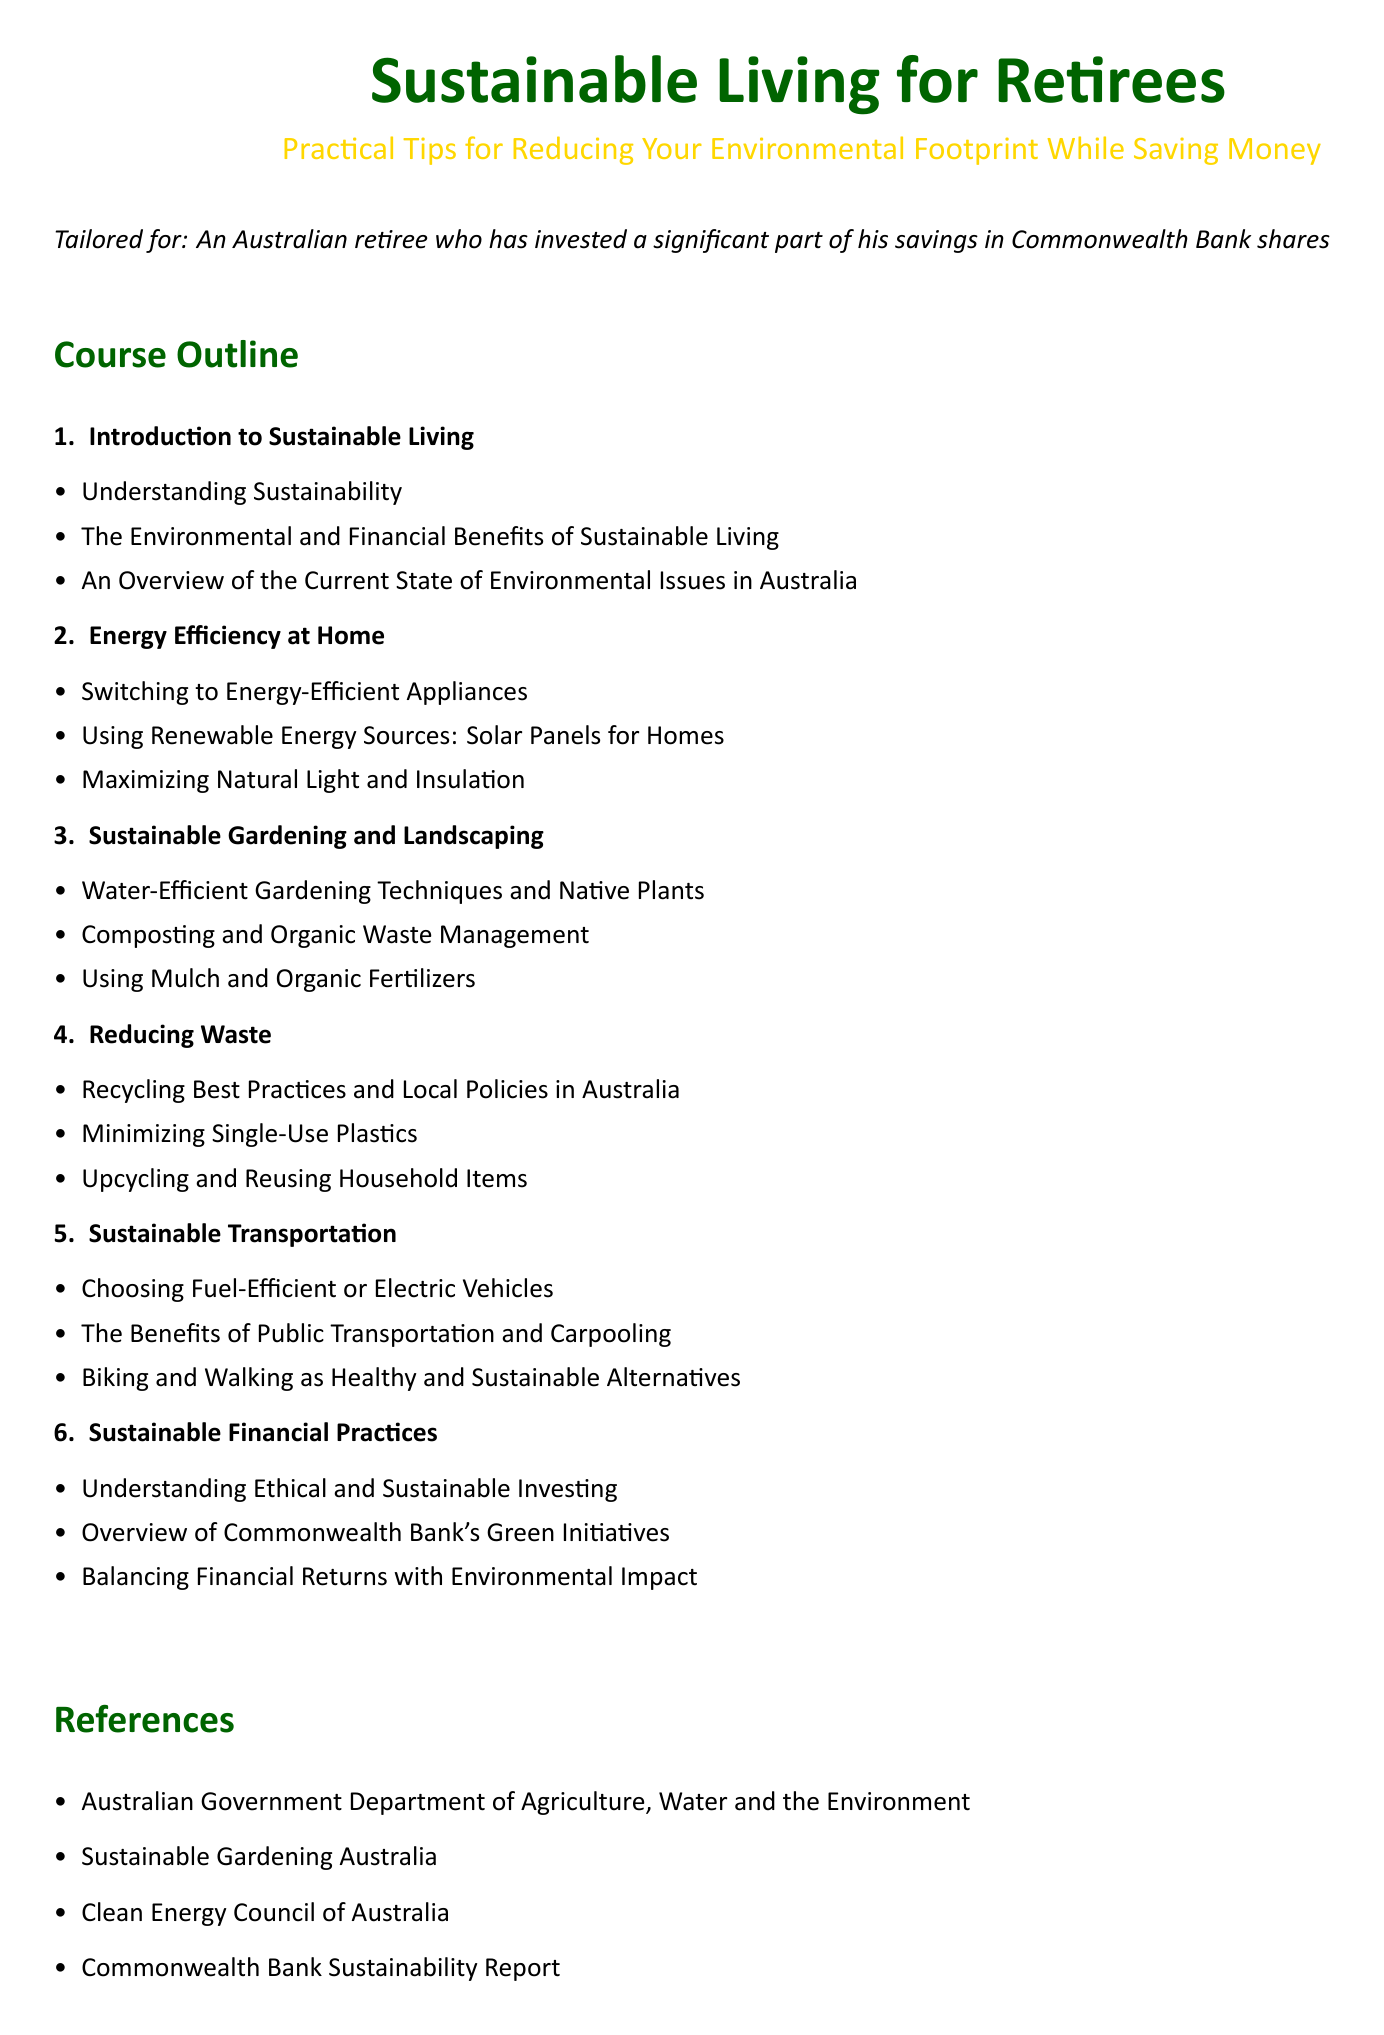What is the title of the document? The title of the document is presented at the top and describes its content related to sustainable living for retirees.
Answer: Sustainable Living for Retirees How many sections are in the course outline? The course outline consists of six numbered sections detailing various aspects of sustainable living.
Answer: 6 What is one of the benefits mentioned for sustainable living? The document lists financial benefits along with environmental ones in the introduction section.
Answer: Financial Benefits What type of gardening techniques are discussed? The syllabus mentions water-efficient gardening as part of sustainable practices for retirees.
Answer: Water-Efficient Gardening Techniques Which bank's green initiatives are overviewed in the syllabus? The document references specific financial practices and initiatives related to sustainability by a well-known Australian bank.
Answer: Commonwealth Bank What is a recommended practice to reduce waste? The section on reducing waste offers strategies that include actions to address plastic usage.
Answer: Minimizing Single-Use Plastics 